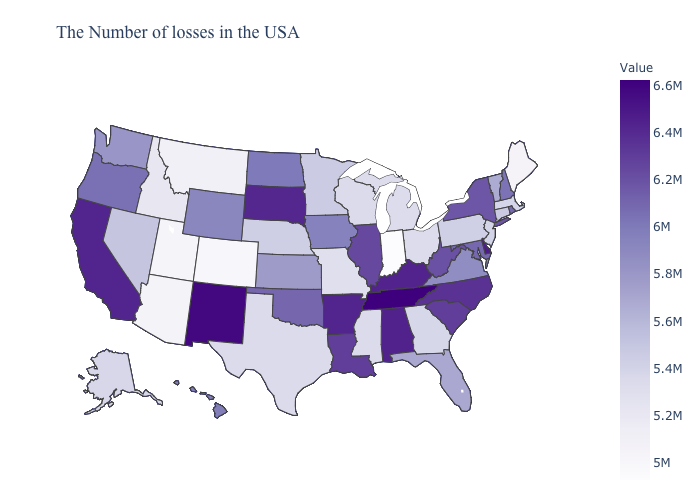Does Oklahoma have a lower value than Louisiana?
Concise answer only. Yes. Does Hawaii have the highest value in the USA?
Give a very brief answer. No. Which states have the highest value in the USA?
Concise answer only. Tennessee. Which states have the lowest value in the Northeast?
Give a very brief answer. Maine. Which states have the highest value in the USA?
Short answer required. Tennessee. 